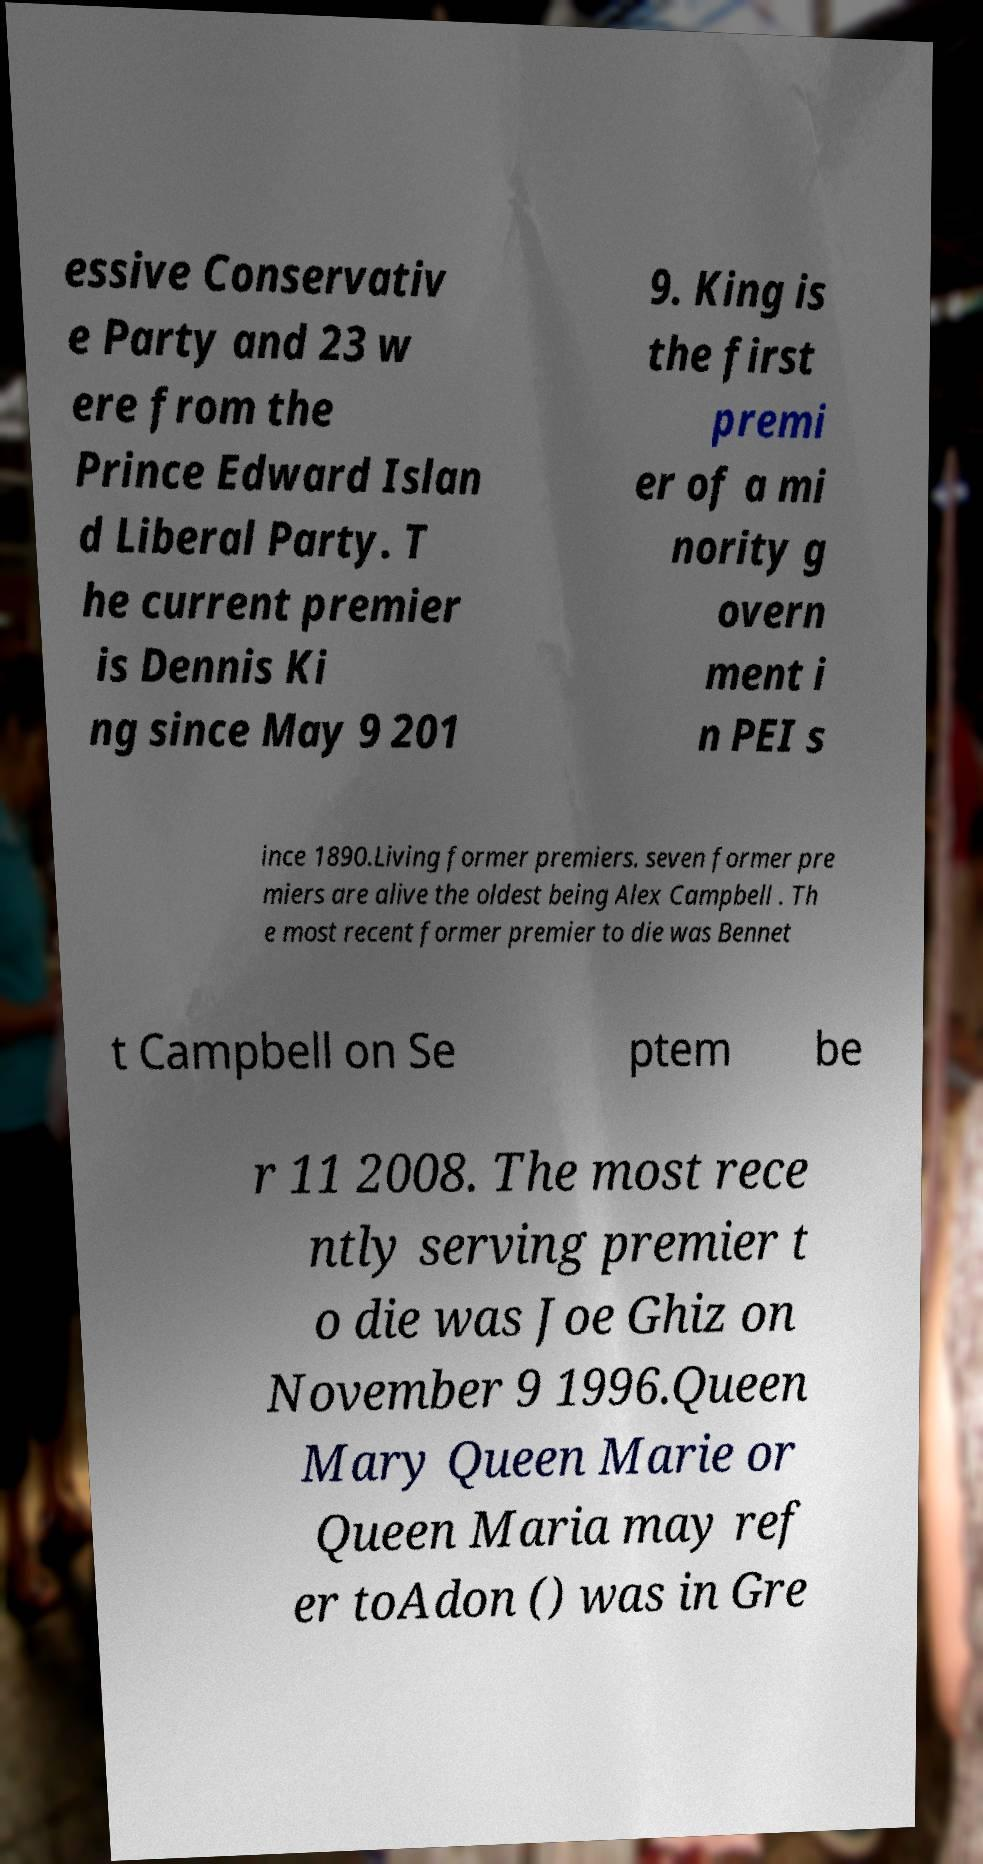Could you extract and type out the text from this image? essive Conservativ e Party and 23 w ere from the Prince Edward Islan d Liberal Party. T he current premier is Dennis Ki ng since May 9 201 9. King is the first premi er of a mi nority g overn ment i n PEI s ince 1890.Living former premiers. seven former pre miers are alive the oldest being Alex Campbell . Th e most recent former premier to die was Bennet t Campbell on Se ptem be r 11 2008. The most rece ntly serving premier t o die was Joe Ghiz on November 9 1996.Queen Mary Queen Marie or Queen Maria may ref er toAdon () was in Gre 